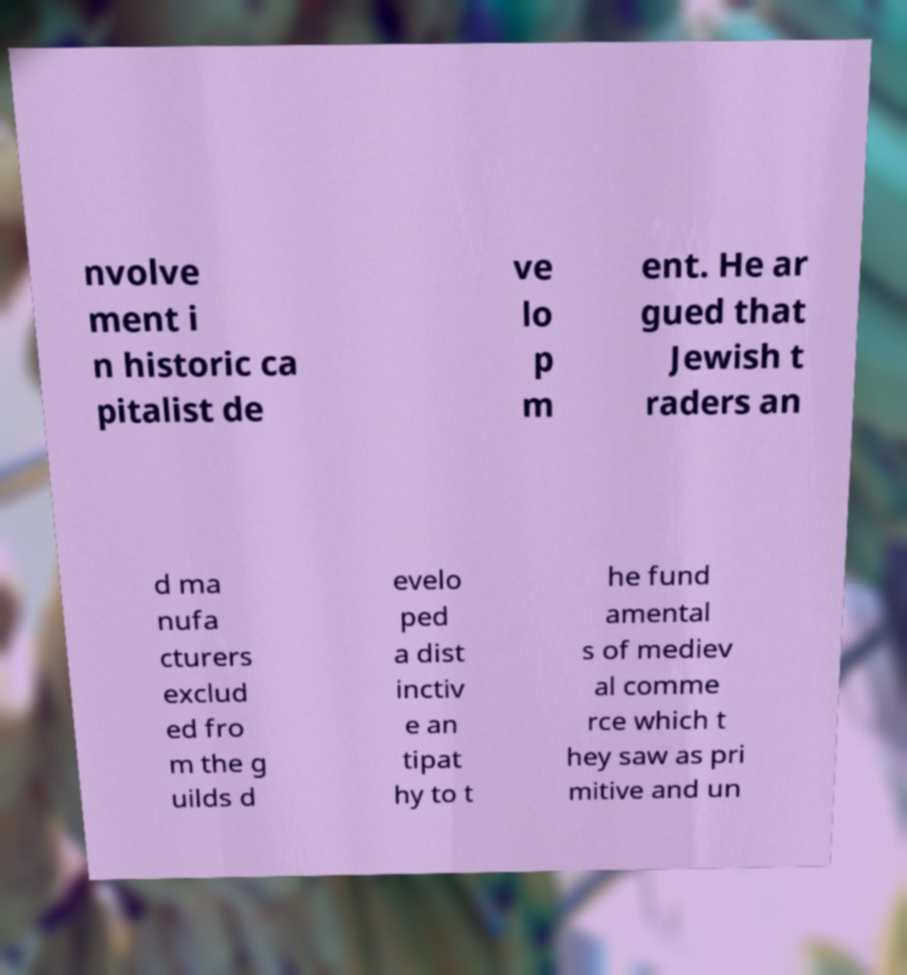Can you accurately transcribe the text from the provided image for me? nvolve ment i n historic ca pitalist de ve lo p m ent. He ar gued that Jewish t raders an d ma nufa cturers exclud ed fro m the g uilds d evelo ped a dist inctiv e an tipat hy to t he fund amental s of mediev al comme rce which t hey saw as pri mitive and un 